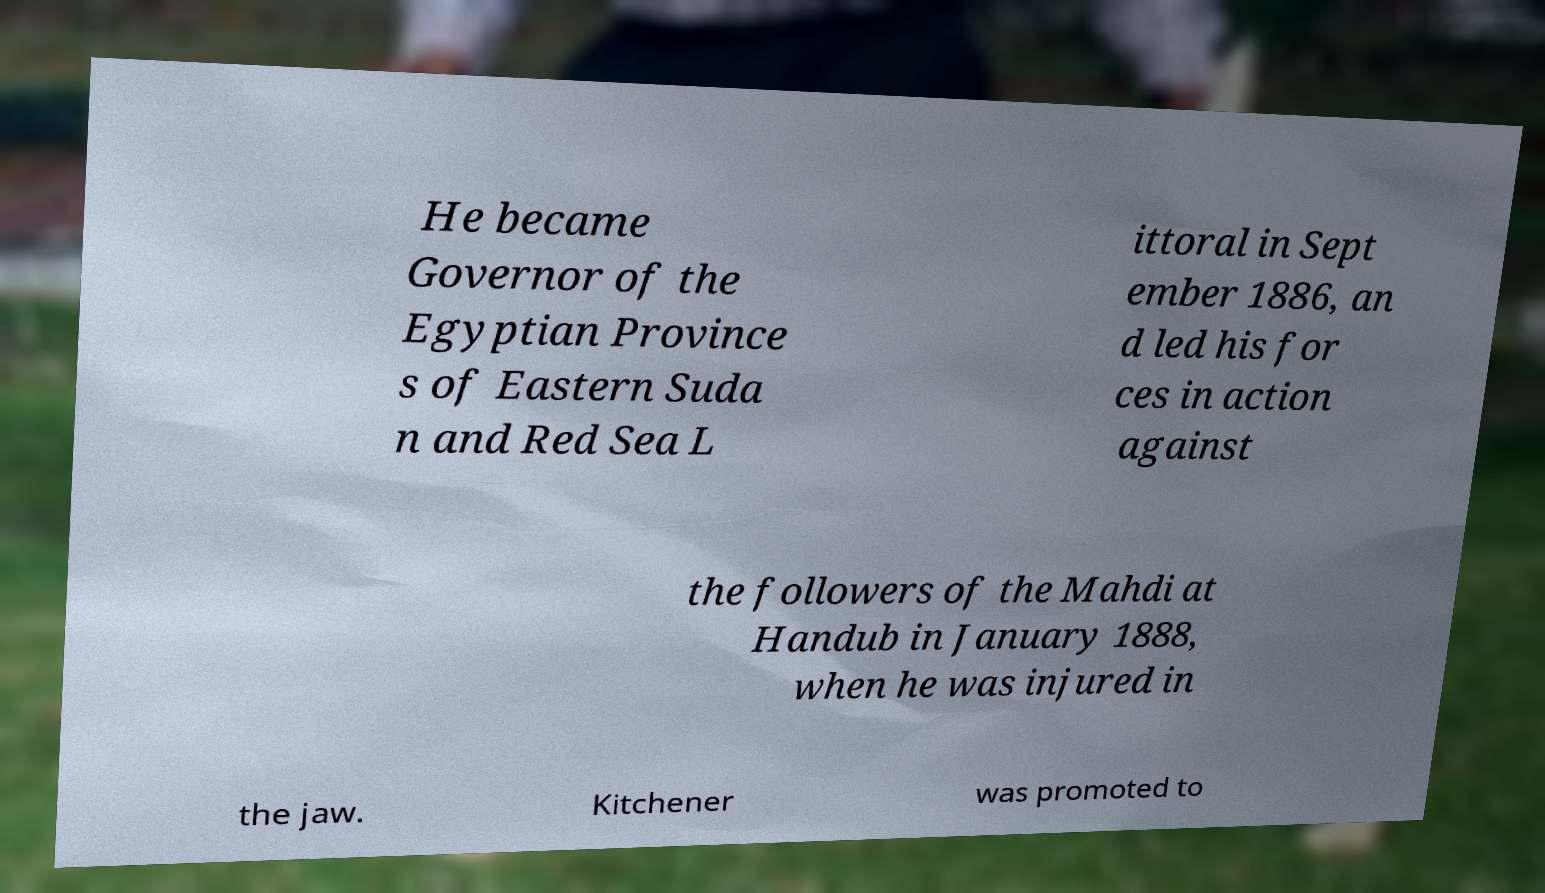Please read and relay the text visible in this image. What does it say? He became Governor of the Egyptian Province s of Eastern Suda n and Red Sea L ittoral in Sept ember 1886, an d led his for ces in action against the followers of the Mahdi at Handub in January 1888, when he was injured in the jaw. Kitchener was promoted to 